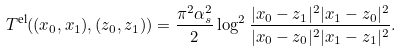Convert formula to latex. <formula><loc_0><loc_0><loc_500><loc_500>T ^ { \text {el} } ( ( x _ { 0 } , x _ { 1 } ) , ( z _ { 0 } , z _ { 1 } ) ) = \frac { \pi ^ { 2 } \alpha _ { s } ^ { 2 } } { 2 } \log ^ { 2 } \frac { | x _ { 0 } - z _ { 1 } | ^ { 2 } | x _ { 1 } - z _ { 0 } | ^ { 2 } } { | x _ { 0 } - z _ { 0 } | ^ { 2 } | x _ { 1 } - z _ { 1 } | ^ { 2 } } .</formula> 